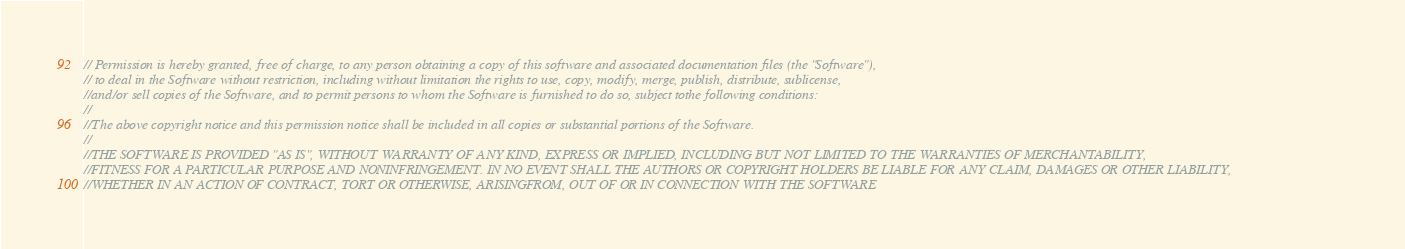Convert code to text. <code><loc_0><loc_0><loc_500><loc_500><_Go_>// Permission is hereby granted, free of charge, to any person obtaining a copy of this software and associated documentation files (the "Software"),
// to deal in the Software without restriction, including without limitation the rights to use, copy, modify, merge, publish, distribute, sublicense, 
//and/or sell copies of the Software, and to permit persons to whom the Software is furnished to do so, subject tothe following conditions:
//
//The above copyright notice and this permission notice shall be included in all copies or substantial portions of the Software.
//
//THE SOFTWARE IS PROVIDED "AS IS", WITHOUT WARRANTY OF ANY KIND, EXPRESS OR IMPLIED, INCLUDING BUT NOT LIMITED TO THE WARRANTIES OF MERCHANTABILITY,
//FITNESS FOR A PARTICULAR PURPOSE AND NONINFRINGEMENT. IN NO EVENT SHALL THE AUTHORS OR COPYRIGHT HOLDERS BE LIABLE FOR ANY CLAIM, DAMAGES OR OTHER LIABILITY, 
//WHETHER IN AN ACTION OF CONTRACT, TORT OR OTHERWISE, ARISINGFROM, OUT OF OR IN CONNECTION WITH THE SOFTWARE</code> 